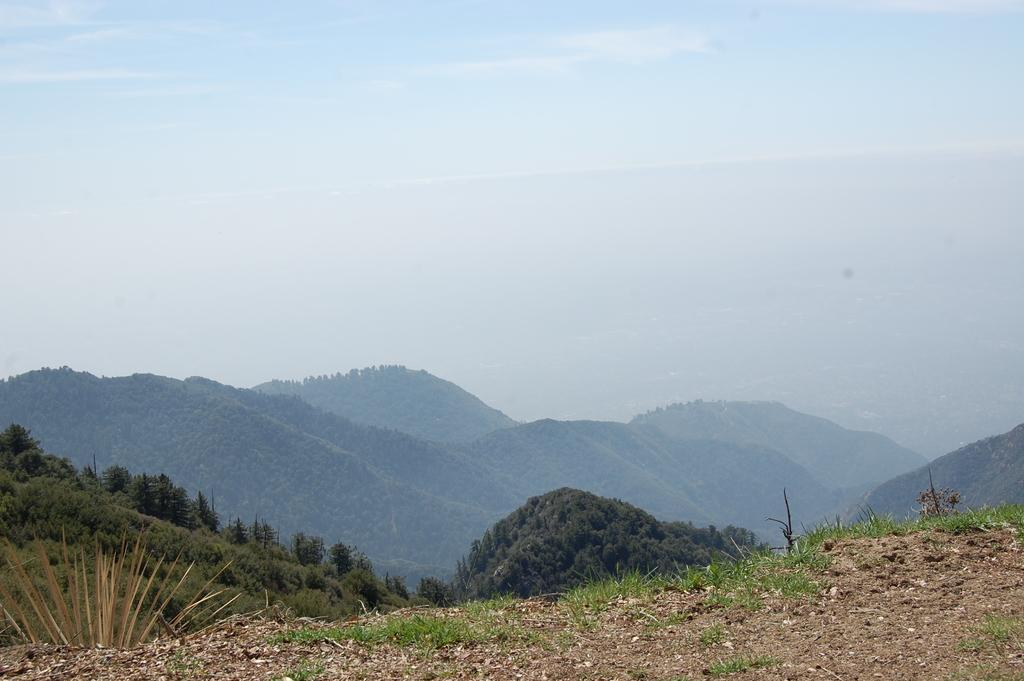What type of vegetation can be seen on the hills in the image? There are trees on the hills in the image. How would you describe the sky in the image? The sky is blue and cloudy in the image. Where is the button located in the image? There is no button present in the image. What type of nut can be seen growing on the trees in the image? There are no nuts visible in the image, as the trees are not specified to be nut-bearing trees. 